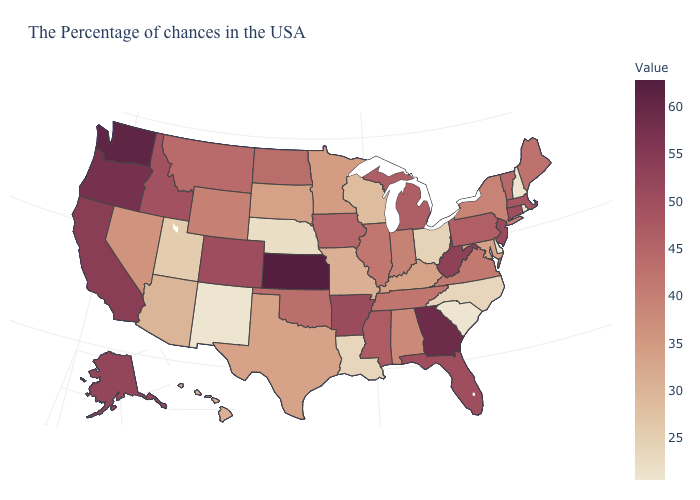Among the states that border Colorado , which have the lowest value?
Answer briefly. New Mexico. Does the map have missing data?
Write a very short answer. No. Among the states that border New Jersey , which have the highest value?
Give a very brief answer. Pennsylvania. Which states have the highest value in the USA?
Write a very short answer. Kansas. 